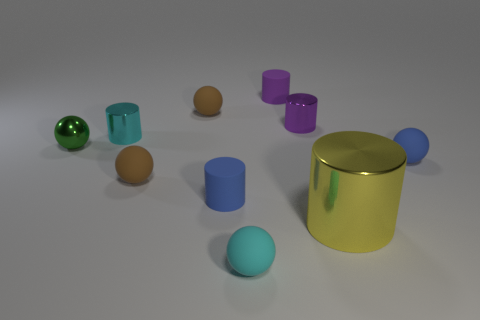Subtract all yellow spheres. Subtract all gray cylinders. How many spheres are left? 5 Subtract all large cyan cylinders. Subtract all tiny metal cylinders. How many objects are left? 8 Add 5 small purple shiny cylinders. How many small purple shiny cylinders are left? 6 Add 5 large red shiny things. How many large red shiny things exist? 5 Subtract 0 gray cylinders. How many objects are left? 10 